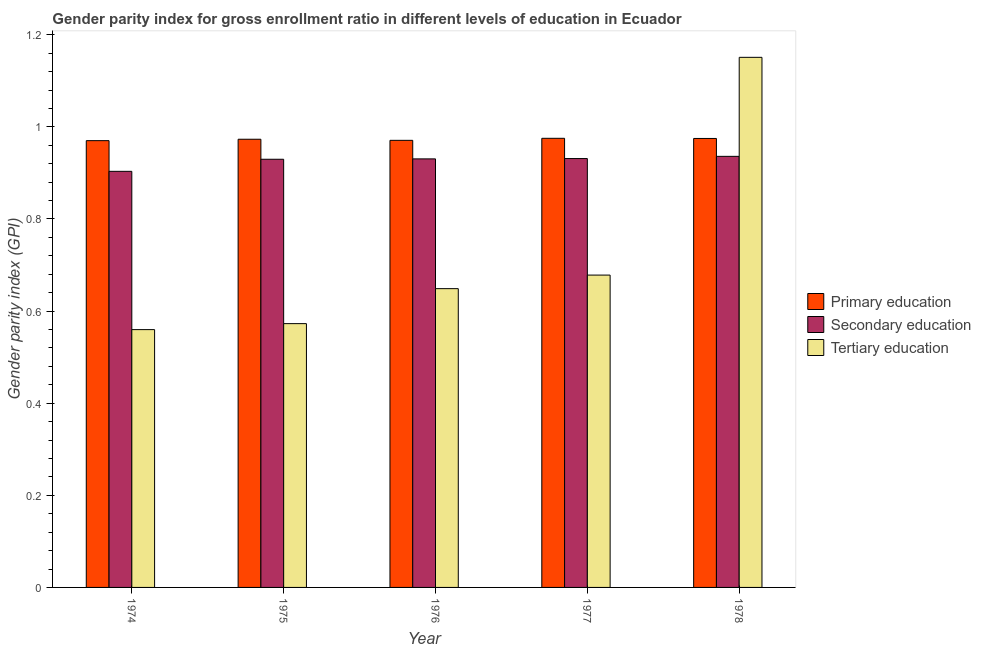How many different coloured bars are there?
Ensure brevity in your answer.  3. Are the number of bars per tick equal to the number of legend labels?
Provide a succinct answer. Yes. How many bars are there on the 4th tick from the left?
Provide a short and direct response. 3. What is the label of the 5th group of bars from the left?
Offer a very short reply. 1978. In how many cases, is the number of bars for a given year not equal to the number of legend labels?
Provide a succinct answer. 0. What is the gender parity index in tertiary education in 1975?
Offer a terse response. 0.57. Across all years, what is the maximum gender parity index in secondary education?
Your answer should be compact. 0.94. Across all years, what is the minimum gender parity index in tertiary education?
Ensure brevity in your answer.  0.56. In which year was the gender parity index in primary education minimum?
Provide a short and direct response. 1974. What is the total gender parity index in primary education in the graph?
Provide a short and direct response. 4.86. What is the difference between the gender parity index in tertiary education in 1974 and that in 1976?
Provide a succinct answer. -0.09. What is the difference between the gender parity index in tertiary education in 1975 and the gender parity index in secondary education in 1976?
Your response must be concise. -0.08. What is the average gender parity index in primary education per year?
Make the answer very short. 0.97. In how many years, is the gender parity index in secondary education greater than 0.24000000000000002?
Make the answer very short. 5. What is the ratio of the gender parity index in secondary education in 1975 to that in 1978?
Your answer should be very brief. 0.99. Is the gender parity index in primary education in 1975 less than that in 1976?
Offer a terse response. No. Is the difference between the gender parity index in secondary education in 1977 and 1978 greater than the difference between the gender parity index in primary education in 1977 and 1978?
Your response must be concise. No. What is the difference between the highest and the second highest gender parity index in secondary education?
Your response must be concise. 0. What is the difference between the highest and the lowest gender parity index in primary education?
Your answer should be compact. 0.01. In how many years, is the gender parity index in primary education greater than the average gender parity index in primary education taken over all years?
Make the answer very short. 3. Is the sum of the gender parity index in secondary education in 1974 and 1976 greater than the maximum gender parity index in primary education across all years?
Your answer should be very brief. Yes. What does the 2nd bar from the right in 1975 represents?
Provide a succinct answer. Secondary education. Are all the bars in the graph horizontal?
Give a very brief answer. No. What is the difference between two consecutive major ticks on the Y-axis?
Your answer should be compact. 0.2. Are the values on the major ticks of Y-axis written in scientific E-notation?
Give a very brief answer. No. Does the graph contain grids?
Give a very brief answer. No. Where does the legend appear in the graph?
Provide a succinct answer. Center right. What is the title of the graph?
Provide a short and direct response. Gender parity index for gross enrollment ratio in different levels of education in Ecuador. Does "Other sectors" appear as one of the legend labels in the graph?
Ensure brevity in your answer.  No. What is the label or title of the X-axis?
Provide a short and direct response. Year. What is the label or title of the Y-axis?
Make the answer very short. Gender parity index (GPI). What is the Gender parity index (GPI) of Primary education in 1974?
Offer a terse response. 0.97. What is the Gender parity index (GPI) of Secondary education in 1974?
Ensure brevity in your answer.  0.9. What is the Gender parity index (GPI) in Tertiary education in 1974?
Your answer should be very brief. 0.56. What is the Gender parity index (GPI) in Primary education in 1975?
Offer a terse response. 0.97. What is the Gender parity index (GPI) in Secondary education in 1975?
Ensure brevity in your answer.  0.93. What is the Gender parity index (GPI) in Tertiary education in 1975?
Your answer should be compact. 0.57. What is the Gender parity index (GPI) in Primary education in 1976?
Your answer should be very brief. 0.97. What is the Gender parity index (GPI) of Secondary education in 1976?
Your answer should be compact. 0.93. What is the Gender parity index (GPI) of Tertiary education in 1976?
Offer a terse response. 0.65. What is the Gender parity index (GPI) in Primary education in 1977?
Offer a terse response. 0.98. What is the Gender parity index (GPI) of Secondary education in 1977?
Offer a terse response. 0.93. What is the Gender parity index (GPI) of Tertiary education in 1977?
Your answer should be compact. 0.68. What is the Gender parity index (GPI) of Primary education in 1978?
Your answer should be very brief. 0.97. What is the Gender parity index (GPI) in Secondary education in 1978?
Provide a short and direct response. 0.94. What is the Gender parity index (GPI) in Tertiary education in 1978?
Provide a short and direct response. 1.15. Across all years, what is the maximum Gender parity index (GPI) in Primary education?
Provide a short and direct response. 0.98. Across all years, what is the maximum Gender parity index (GPI) in Secondary education?
Provide a short and direct response. 0.94. Across all years, what is the maximum Gender parity index (GPI) of Tertiary education?
Offer a terse response. 1.15. Across all years, what is the minimum Gender parity index (GPI) in Primary education?
Offer a terse response. 0.97. Across all years, what is the minimum Gender parity index (GPI) of Secondary education?
Offer a terse response. 0.9. Across all years, what is the minimum Gender parity index (GPI) of Tertiary education?
Give a very brief answer. 0.56. What is the total Gender parity index (GPI) in Primary education in the graph?
Provide a short and direct response. 4.86. What is the total Gender parity index (GPI) in Secondary education in the graph?
Offer a very short reply. 4.63. What is the total Gender parity index (GPI) in Tertiary education in the graph?
Your answer should be compact. 3.61. What is the difference between the Gender parity index (GPI) in Primary education in 1974 and that in 1975?
Make the answer very short. -0. What is the difference between the Gender parity index (GPI) in Secondary education in 1974 and that in 1975?
Keep it short and to the point. -0.03. What is the difference between the Gender parity index (GPI) in Tertiary education in 1974 and that in 1975?
Your answer should be very brief. -0.01. What is the difference between the Gender parity index (GPI) of Primary education in 1974 and that in 1976?
Your answer should be very brief. -0. What is the difference between the Gender parity index (GPI) in Secondary education in 1974 and that in 1976?
Offer a terse response. -0.03. What is the difference between the Gender parity index (GPI) of Tertiary education in 1974 and that in 1976?
Provide a short and direct response. -0.09. What is the difference between the Gender parity index (GPI) in Primary education in 1974 and that in 1977?
Ensure brevity in your answer.  -0.01. What is the difference between the Gender parity index (GPI) of Secondary education in 1974 and that in 1977?
Offer a terse response. -0.03. What is the difference between the Gender parity index (GPI) of Tertiary education in 1974 and that in 1977?
Give a very brief answer. -0.12. What is the difference between the Gender parity index (GPI) in Primary education in 1974 and that in 1978?
Your answer should be compact. -0. What is the difference between the Gender parity index (GPI) in Secondary education in 1974 and that in 1978?
Give a very brief answer. -0.03. What is the difference between the Gender parity index (GPI) in Tertiary education in 1974 and that in 1978?
Provide a short and direct response. -0.59. What is the difference between the Gender parity index (GPI) of Primary education in 1975 and that in 1976?
Offer a very short reply. 0. What is the difference between the Gender parity index (GPI) in Secondary education in 1975 and that in 1976?
Give a very brief answer. -0. What is the difference between the Gender parity index (GPI) of Tertiary education in 1975 and that in 1976?
Provide a succinct answer. -0.08. What is the difference between the Gender parity index (GPI) in Primary education in 1975 and that in 1977?
Make the answer very short. -0. What is the difference between the Gender parity index (GPI) of Secondary education in 1975 and that in 1977?
Your response must be concise. -0. What is the difference between the Gender parity index (GPI) of Tertiary education in 1975 and that in 1977?
Provide a short and direct response. -0.11. What is the difference between the Gender parity index (GPI) in Primary education in 1975 and that in 1978?
Provide a short and direct response. -0. What is the difference between the Gender parity index (GPI) of Secondary education in 1975 and that in 1978?
Offer a terse response. -0.01. What is the difference between the Gender parity index (GPI) of Tertiary education in 1975 and that in 1978?
Keep it short and to the point. -0.58. What is the difference between the Gender parity index (GPI) of Primary education in 1976 and that in 1977?
Provide a succinct answer. -0. What is the difference between the Gender parity index (GPI) of Secondary education in 1976 and that in 1977?
Give a very brief answer. -0. What is the difference between the Gender parity index (GPI) in Tertiary education in 1976 and that in 1977?
Your response must be concise. -0.03. What is the difference between the Gender parity index (GPI) in Primary education in 1976 and that in 1978?
Offer a very short reply. -0. What is the difference between the Gender parity index (GPI) in Secondary education in 1976 and that in 1978?
Make the answer very short. -0.01. What is the difference between the Gender parity index (GPI) of Tertiary education in 1976 and that in 1978?
Your response must be concise. -0.5. What is the difference between the Gender parity index (GPI) in Secondary education in 1977 and that in 1978?
Offer a very short reply. -0. What is the difference between the Gender parity index (GPI) in Tertiary education in 1977 and that in 1978?
Provide a succinct answer. -0.47. What is the difference between the Gender parity index (GPI) in Primary education in 1974 and the Gender parity index (GPI) in Secondary education in 1975?
Your response must be concise. 0.04. What is the difference between the Gender parity index (GPI) in Primary education in 1974 and the Gender parity index (GPI) in Tertiary education in 1975?
Give a very brief answer. 0.4. What is the difference between the Gender parity index (GPI) of Secondary education in 1974 and the Gender parity index (GPI) of Tertiary education in 1975?
Give a very brief answer. 0.33. What is the difference between the Gender parity index (GPI) of Primary education in 1974 and the Gender parity index (GPI) of Secondary education in 1976?
Provide a short and direct response. 0.04. What is the difference between the Gender parity index (GPI) of Primary education in 1974 and the Gender parity index (GPI) of Tertiary education in 1976?
Give a very brief answer. 0.32. What is the difference between the Gender parity index (GPI) in Secondary education in 1974 and the Gender parity index (GPI) in Tertiary education in 1976?
Offer a terse response. 0.25. What is the difference between the Gender parity index (GPI) in Primary education in 1974 and the Gender parity index (GPI) in Secondary education in 1977?
Give a very brief answer. 0.04. What is the difference between the Gender parity index (GPI) of Primary education in 1974 and the Gender parity index (GPI) of Tertiary education in 1977?
Keep it short and to the point. 0.29. What is the difference between the Gender parity index (GPI) in Secondary education in 1974 and the Gender parity index (GPI) in Tertiary education in 1977?
Give a very brief answer. 0.23. What is the difference between the Gender parity index (GPI) in Primary education in 1974 and the Gender parity index (GPI) in Secondary education in 1978?
Provide a succinct answer. 0.03. What is the difference between the Gender parity index (GPI) in Primary education in 1974 and the Gender parity index (GPI) in Tertiary education in 1978?
Your response must be concise. -0.18. What is the difference between the Gender parity index (GPI) of Secondary education in 1974 and the Gender parity index (GPI) of Tertiary education in 1978?
Your answer should be compact. -0.25. What is the difference between the Gender parity index (GPI) of Primary education in 1975 and the Gender parity index (GPI) of Secondary education in 1976?
Provide a succinct answer. 0.04. What is the difference between the Gender parity index (GPI) in Primary education in 1975 and the Gender parity index (GPI) in Tertiary education in 1976?
Provide a short and direct response. 0.32. What is the difference between the Gender parity index (GPI) of Secondary education in 1975 and the Gender parity index (GPI) of Tertiary education in 1976?
Keep it short and to the point. 0.28. What is the difference between the Gender parity index (GPI) of Primary education in 1975 and the Gender parity index (GPI) of Secondary education in 1977?
Offer a terse response. 0.04. What is the difference between the Gender parity index (GPI) of Primary education in 1975 and the Gender parity index (GPI) of Tertiary education in 1977?
Ensure brevity in your answer.  0.29. What is the difference between the Gender parity index (GPI) of Secondary education in 1975 and the Gender parity index (GPI) of Tertiary education in 1977?
Your answer should be compact. 0.25. What is the difference between the Gender parity index (GPI) in Primary education in 1975 and the Gender parity index (GPI) in Secondary education in 1978?
Ensure brevity in your answer.  0.04. What is the difference between the Gender parity index (GPI) in Primary education in 1975 and the Gender parity index (GPI) in Tertiary education in 1978?
Your answer should be very brief. -0.18. What is the difference between the Gender parity index (GPI) in Secondary education in 1975 and the Gender parity index (GPI) in Tertiary education in 1978?
Your answer should be compact. -0.22. What is the difference between the Gender parity index (GPI) of Primary education in 1976 and the Gender parity index (GPI) of Secondary education in 1977?
Provide a succinct answer. 0.04. What is the difference between the Gender parity index (GPI) in Primary education in 1976 and the Gender parity index (GPI) in Tertiary education in 1977?
Provide a short and direct response. 0.29. What is the difference between the Gender parity index (GPI) in Secondary education in 1976 and the Gender parity index (GPI) in Tertiary education in 1977?
Offer a very short reply. 0.25. What is the difference between the Gender parity index (GPI) in Primary education in 1976 and the Gender parity index (GPI) in Secondary education in 1978?
Your answer should be compact. 0.03. What is the difference between the Gender parity index (GPI) in Primary education in 1976 and the Gender parity index (GPI) in Tertiary education in 1978?
Your answer should be very brief. -0.18. What is the difference between the Gender parity index (GPI) in Secondary education in 1976 and the Gender parity index (GPI) in Tertiary education in 1978?
Offer a terse response. -0.22. What is the difference between the Gender parity index (GPI) of Primary education in 1977 and the Gender parity index (GPI) of Secondary education in 1978?
Keep it short and to the point. 0.04. What is the difference between the Gender parity index (GPI) in Primary education in 1977 and the Gender parity index (GPI) in Tertiary education in 1978?
Your answer should be compact. -0.18. What is the difference between the Gender parity index (GPI) in Secondary education in 1977 and the Gender parity index (GPI) in Tertiary education in 1978?
Your answer should be very brief. -0.22. What is the average Gender parity index (GPI) in Primary education per year?
Provide a succinct answer. 0.97. What is the average Gender parity index (GPI) in Secondary education per year?
Offer a terse response. 0.93. What is the average Gender parity index (GPI) in Tertiary education per year?
Your answer should be compact. 0.72. In the year 1974, what is the difference between the Gender parity index (GPI) in Primary education and Gender parity index (GPI) in Secondary education?
Ensure brevity in your answer.  0.07. In the year 1974, what is the difference between the Gender parity index (GPI) in Primary education and Gender parity index (GPI) in Tertiary education?
Make the answer very short. 0.41. In the year 1974, what is the difference between the Gender parity index (GPI) in Secondary education and Gender parity index (GPI) in Tertiary education?
Provide a short and direct response. 0.34. In the year 1975, what is the difference between the Gender parity index (GPI) in Primary education and Gender parity index (GPI) in Secondary education?
Provide a succinct answer. 0.04. In the year 1975, what is the difference between the Gender parity index (GPI) of Primary education and Gender parity index (GPI) of Tertiary education?
Keep it short and to the point. 0.4. In the year 1975, what is the difference between the Gender parity index (GPI) in Secondary education and Gender parity index (GPI) in Tertiary education?
Give a very brief answer. 0.36. In the year 1976, what is the difference between the Gender parity index (GPI) of Primary education and Gender parity index (GPI) of Secondary education?
Offer a very short reply. 0.04. In the year 1976, what is the difference between the Gender parity index (GPI) of Primary education and Gender parity index (GPI) of Tertiary education?
Your answer should be compact. 0.32. In the year 1976, what is the difference between the Gender parity index (GPI) of Secondary education and Gender parity index (GPI) of Tertiary education?
Ensure brevity in your answer.  0.28. In the year 1977, what is the difference between the Gender parity index (GPI) in Primary education and Gender parity index (GPI) in Secondary education?
Offer a terse response. 0.04. In the year 1977, what is the difference between the Gender parity index (GPI) in Primary education and Gender parity index (GPI) in Tertiary education?
Make the answer very short. 0.3. In the year 1977, what is the difference between the Gender parity index (GPI) in Secondary education and Gender parity index (GPI) in Tertiary education?
Your response must be concise. 0.25. In the year 1978, what is the difference between the Gender parity index (GPI) of Primary education and Gender parity index (GPI) of Secondary education?
Offer a terse response. 0.04. In the year 1978, what is the difference between the Gender parity index (GPI) of Primary education and Gender parity index (GPI) of Tertiary education?
Offer a very short reply. -0.18. In the year 1978, what is the difference between the Gender parity index (GPI) in Secondary education and Gender parity index (GPI) in Tertiary education?
Make the answer very short. -0.21. What is the ratio of the Gender parity index (GPI) of Primary education in 1974 to that in 1975?
Your response must be concise. 1. What is the ratio of the Gender parity index (GPI) of Secondary education in 1974 to that in 1975?
Your answer should be very brief. 0.97. What is the ratio of the Gender parity index (GPI) of Tertiary education in 1974 to that in 1975?
Ensure brevity in your answer.  0.98. What is the ratio of the Gender parity index (GPI) in Primary education in 1974 to that in 1976?
Ensure brevity in your answer.  1. What is the ratio of the Gender parity index (GPI) in Secondary education in 1974 to that in 1976?
Offer a terse response. 0.97. What is the ratio of the Gender parity index (GPI) of Tertiary education in 1974 to that in 1976?
Your answer should be compact. 0.86. What is the ratio of the Gender parity index (GPI) in Primary education in 1974 to that in 1977?
Provide a succinct answer. 0.99. What is the ratio of the Gender parity index (GPI) in Secondary education in 1974 to that in 1977?
Provide a succinct answer. 0.97. What is the ratio of the Gender parity index (GPI) in Tertiary education in 1974 to that in 1977?
Give a very brief answer. 0.83. What is the ratio of the Gender parity index (GPI) in Secondary education in 1974 to that in 1978?
Make the answer very short. 0.97. What is the ratio of the Gender parity index (GPI) in Tertiary education in 1974 to that in 1978?
Ensure brevity in your answer.  0.49. What is the ratio of the Gender parity index (GPI) of Tertiary education in 1975 to that in 1976?
Offer a terse response. 0.88. What is the ratio of the Gender parity index (GPI) in Secondary education in 1975 to that in 1977?
Provide a short and direct response. 1. What is the ratio of the Gender parity index (GPI) of Tertiary education in 1975 to that in 1977?
Your answer should be very brief. 0.84. What is the ratio of the Gender parity index (GPI) of Tertiary education in 1975 to that in 1978?
Provide a short and direct response. 0.5. What is the ratio of the Gender parity index (GPI) of Primary education in 1976 to that in 1977?
Offer a terse response. 1. What is the ratio of the Gender parity index (GPI) in Tertiary education in 1976 to that in 1977?
Ensure brevity in your answer.  0.96. What is the ratio of the Gender parity index (GPI) in Primary education in 1976 to that in 1978?
Your response must be concise. 1. What is the ratio of the Gender parity index (GPI) in Secondary education in 1976 to that in 1978?
Offer a terse response. 0.99. What is the ratio of the Gender parity index (GPI) of Tertiary education in 1976 to that in 1978?
Your response must be concise. 0.56. What is the ratio of the Gender parity index (GPI) of Tertiary education in 1977 to that in 1978?
Ensure brevity in your answer.  0.59. What is the difference between the highest and the second highest Gender parity index (GPI) in Secondary education?
Offer a very short reply. 0. What is the difference between the highest and the second highest Gender parity index (GPI) of Tertiary education?
Your response must be concise. 0.47. What is the difference between the highest and the lowest Gender parity index (GPI) of Primary education?
Offer a very short reply. 0.01. What is the difference between the highest and the lowest Gender parity index (GPI) in Secondary education?
Your answer should be very brief. 0.03. What is the difference between the highest and the lowest Gender parity index (GPI) of Tertiary education?
Your answer should be very brief. 0.59. 